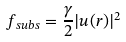<formula> <loc_0><loc_0><loc_500><loc_500>f _ { s u b s } = \frac { \gamma } { 2 } | { u } ( { r } ) | ^ { 2 }</formula> 